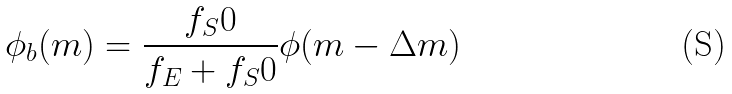Convert formula to latex. <formula><loc_0><loc_0><loc_500><loc_500>\phi _ { b } ( m ) = \frac { f _ { S } 0 } { f _ { E } + f _ { S } 0 } \phi ( m - \Delta m )</formula> 